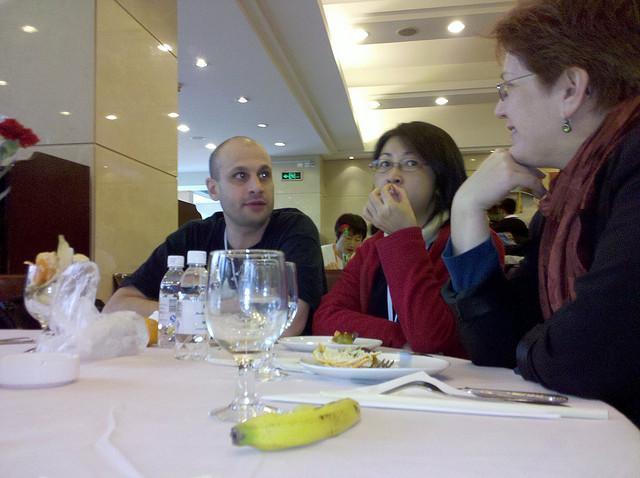How many people are at the table?
Give a very brief answer. 3. How many forks are right side up?
Give a very brief answer. 1. How many people can be seen?
Give a very brief answer. 3. How many of the birds are sitting?
Give a very brief answer. 0. 